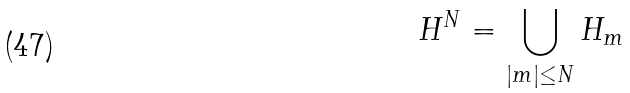Convert formula to latex. <formula><loc_0><loc_0><loc_500><loc_500>H ^ { N } = \bigcup _ { | m | \leq N } H _ { m }</formula> 